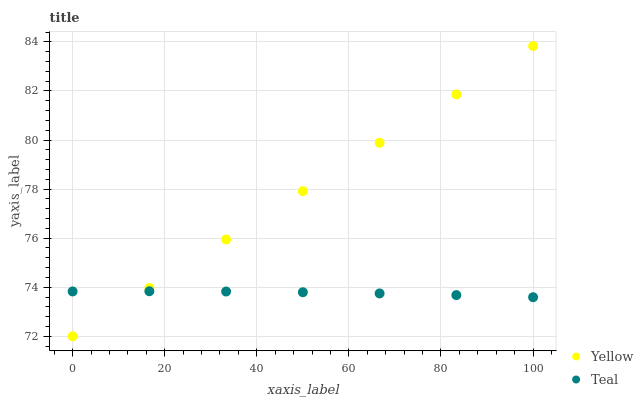Does Teal have the minimum area under the curve?
Answer yes or no. Yes. Does Yellow have the maximum area under the curve?
Answer yes or no. Yes. Does Yellow have the minimum area under the curve?
Answer yes or no. No. Is Yellow the smoothest?
Answer yes or no. Yes. Is Teal the roughest?
Answer yes or no. Yes. Is Yellow the roughest?
Answer yes or no. No. Does Yellow have the lowest value?
Answer yes or no. Yes. Does Yellow have the highest value?
Answer yes or no. Yes. Does Teal intersect Yellow?
Answer yes or no. Yes. Is Teal less than Yellow?
Answer yes or no. No. Is Teal greater than Yellow?
Answer yes or no. No. 